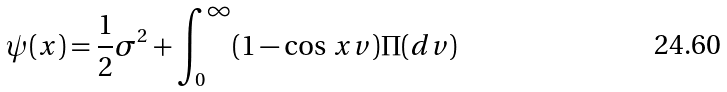Convert formula to latex. <formula><loc_0><loc_0><loc_500><loc_500>\psi ( x ) = \frac { 1 } { 2 } \sigma ^ { 2 } + \int _ { 0 } ^ { \infty } ( 1 - \cos \, x v ) \Pi ( d v )</formula> 